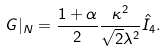<formula> <loc_0><loc_0><loc_500><loc_500>G | _ { N } = { \frac { 1 + \alpha } { 2 } } { \frac { \kappa ^ { 2 } } { \sqrt { 2 } \lambda ^ { 2 } } } \hat { I } _ { 4 } .</formula> 